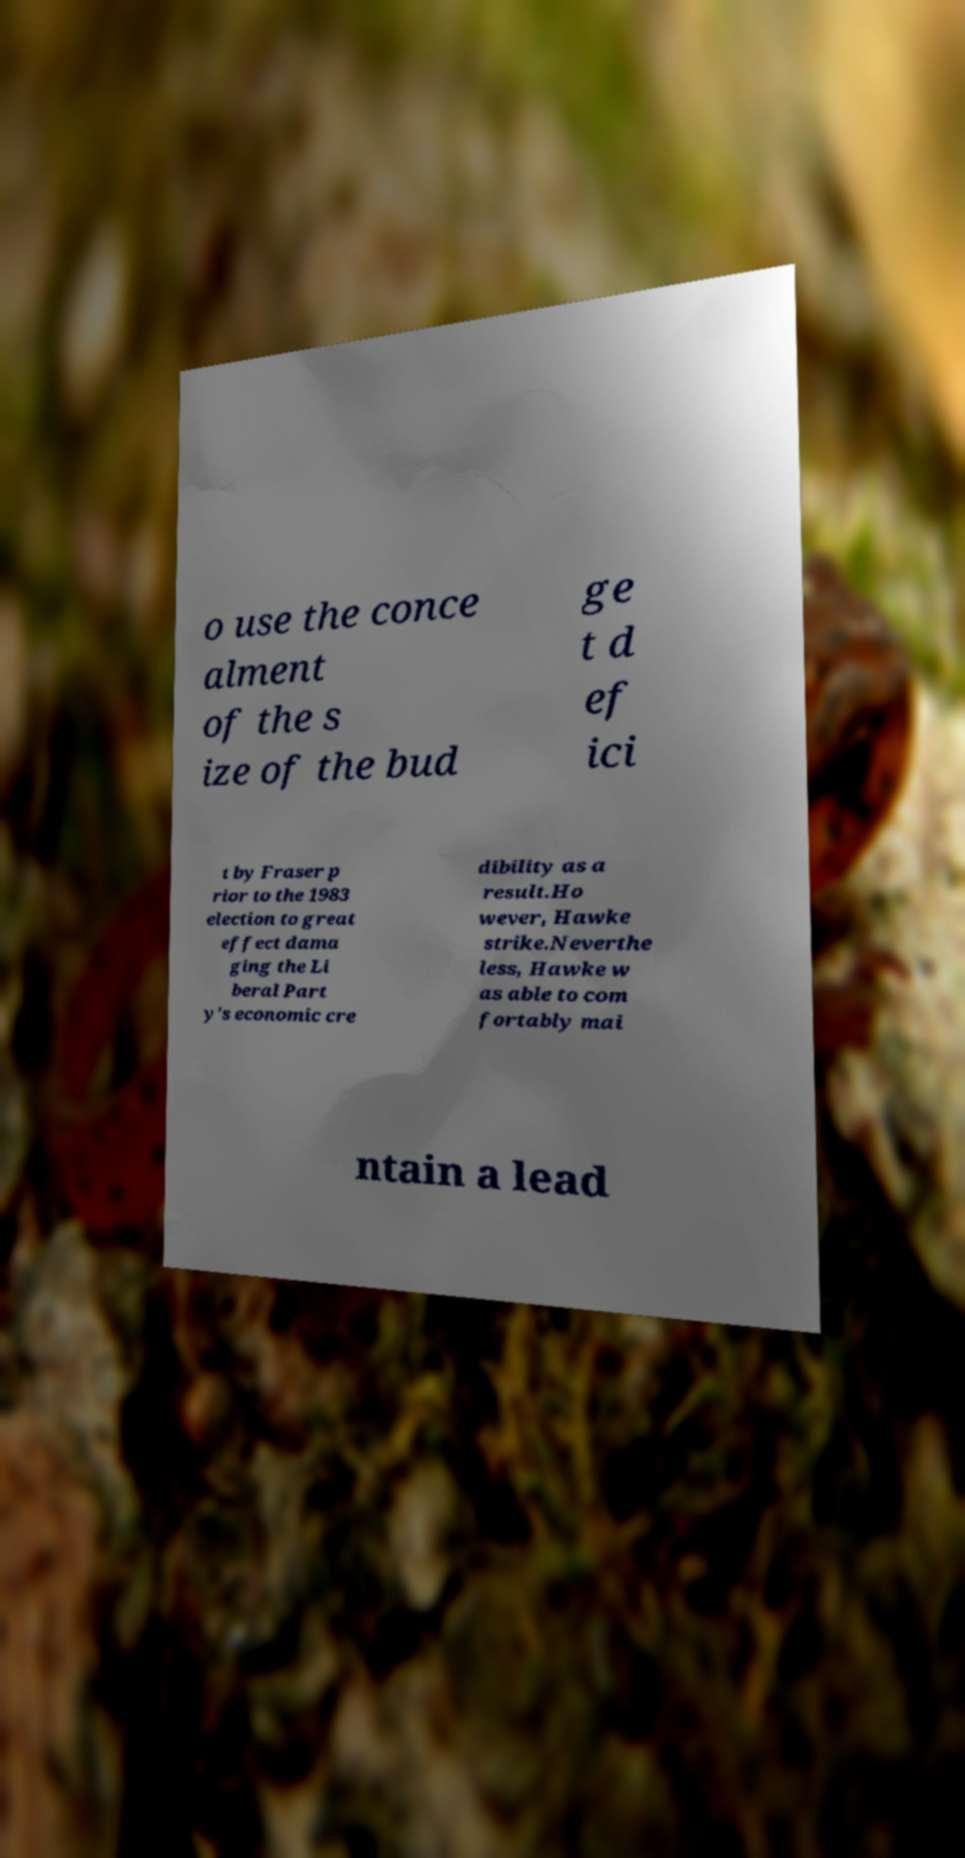Could you assist in decoding the text presented in this image and type it out clearly? o use the conce alment of the s ize of the bud ge t d ef ici t by Fraser p rior to the 1983 election to great effect dama ging the Li beral Part y's economic cre dibility as a result.Ho wever, Hawke strike.Neverthe less, Hawke w as able to com fortably mai ntain a lead 